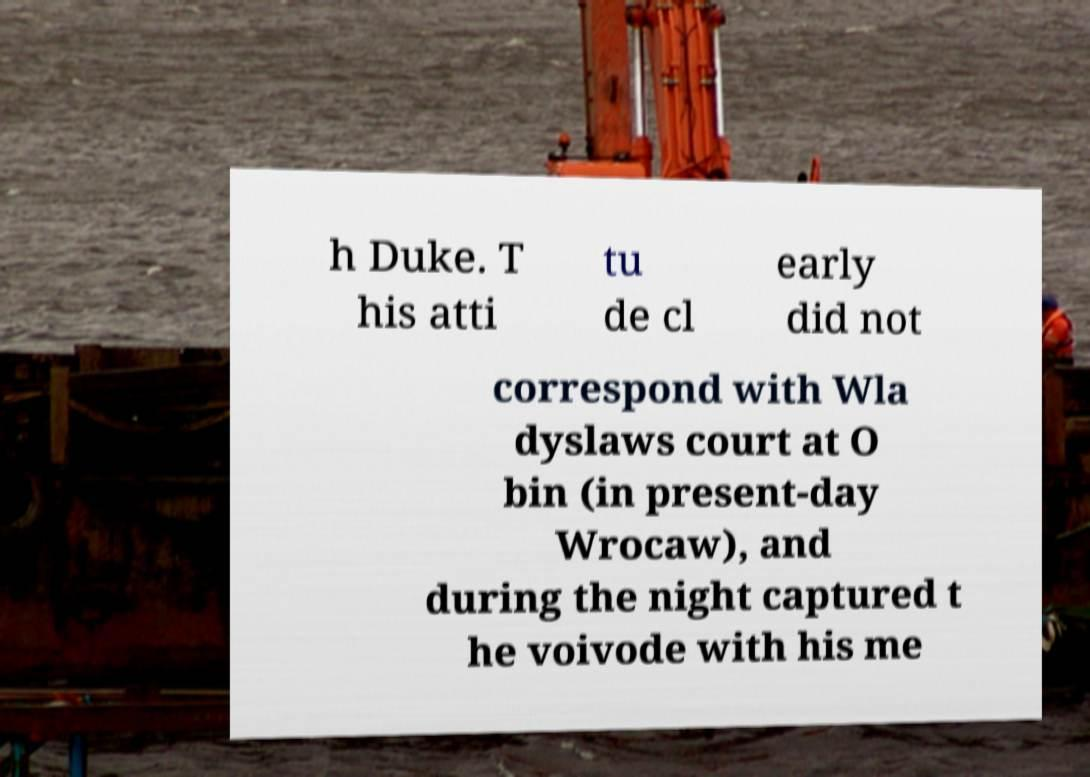Can you read and provide the text displayed in the image?This photo seems to have some interesting text. Can you extract and type it out for me? h Duke. T his atti tu de cl early did not correspond with Wla dyslaws court at O bin (in present-day Wrocaw), and during the night captured t he voivode with his me 